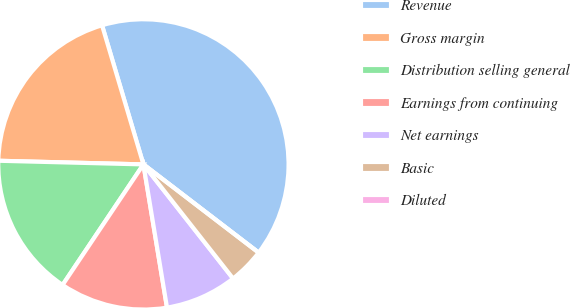<chart> <loc_0><loc_0><loc_500><loc_500><pie_chart><fcel>Revenue<fcel>Gross margin<fcel>Distribution selling general<fcel>Earnings from continuing<fcel>Net earnings<fcel>Basic<fcel>Diluted<nl><fcel>40.0%<fcel>20.0%<fcel>16.0%<fcel>12.0%<fcel>8.0%<fcel>4.0%<fcel>0.0%<nl></chart> 